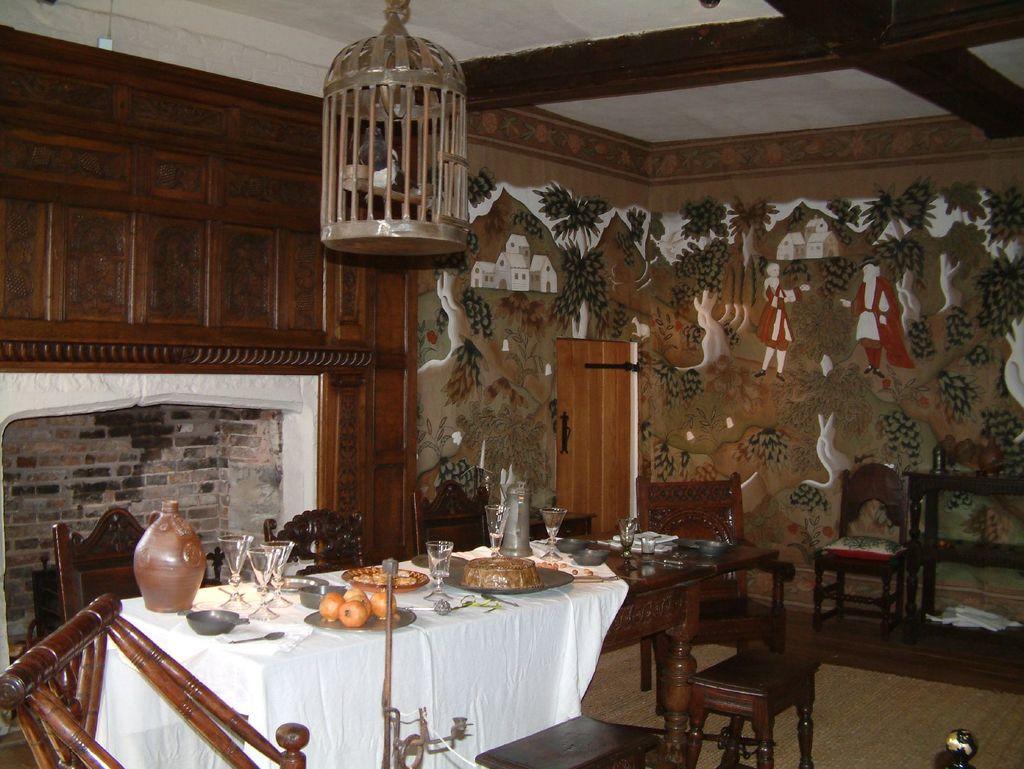Can you describe this image briefly? In this picture I can see few food items, glasses and other things on a dining table. There are chairs in the middle, at the top I can see a cage. In the background there are paintings on the wall, there is a door. 